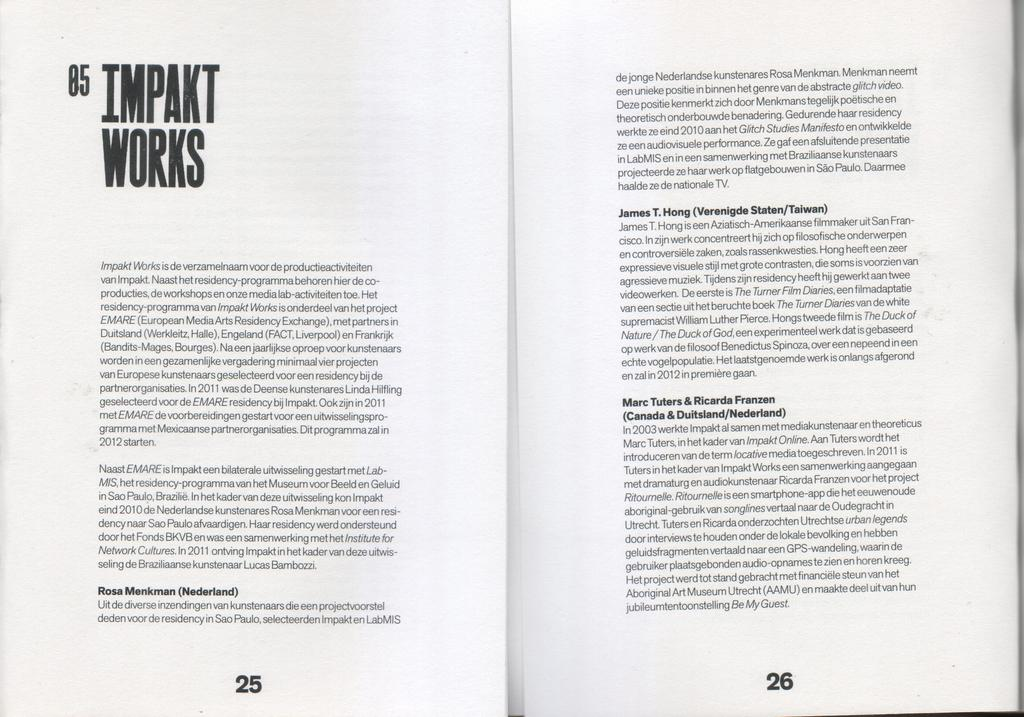<image>
Give a short and clear explanation of the subsequent image. A German language book is opened to a section titled Impakt Works. 